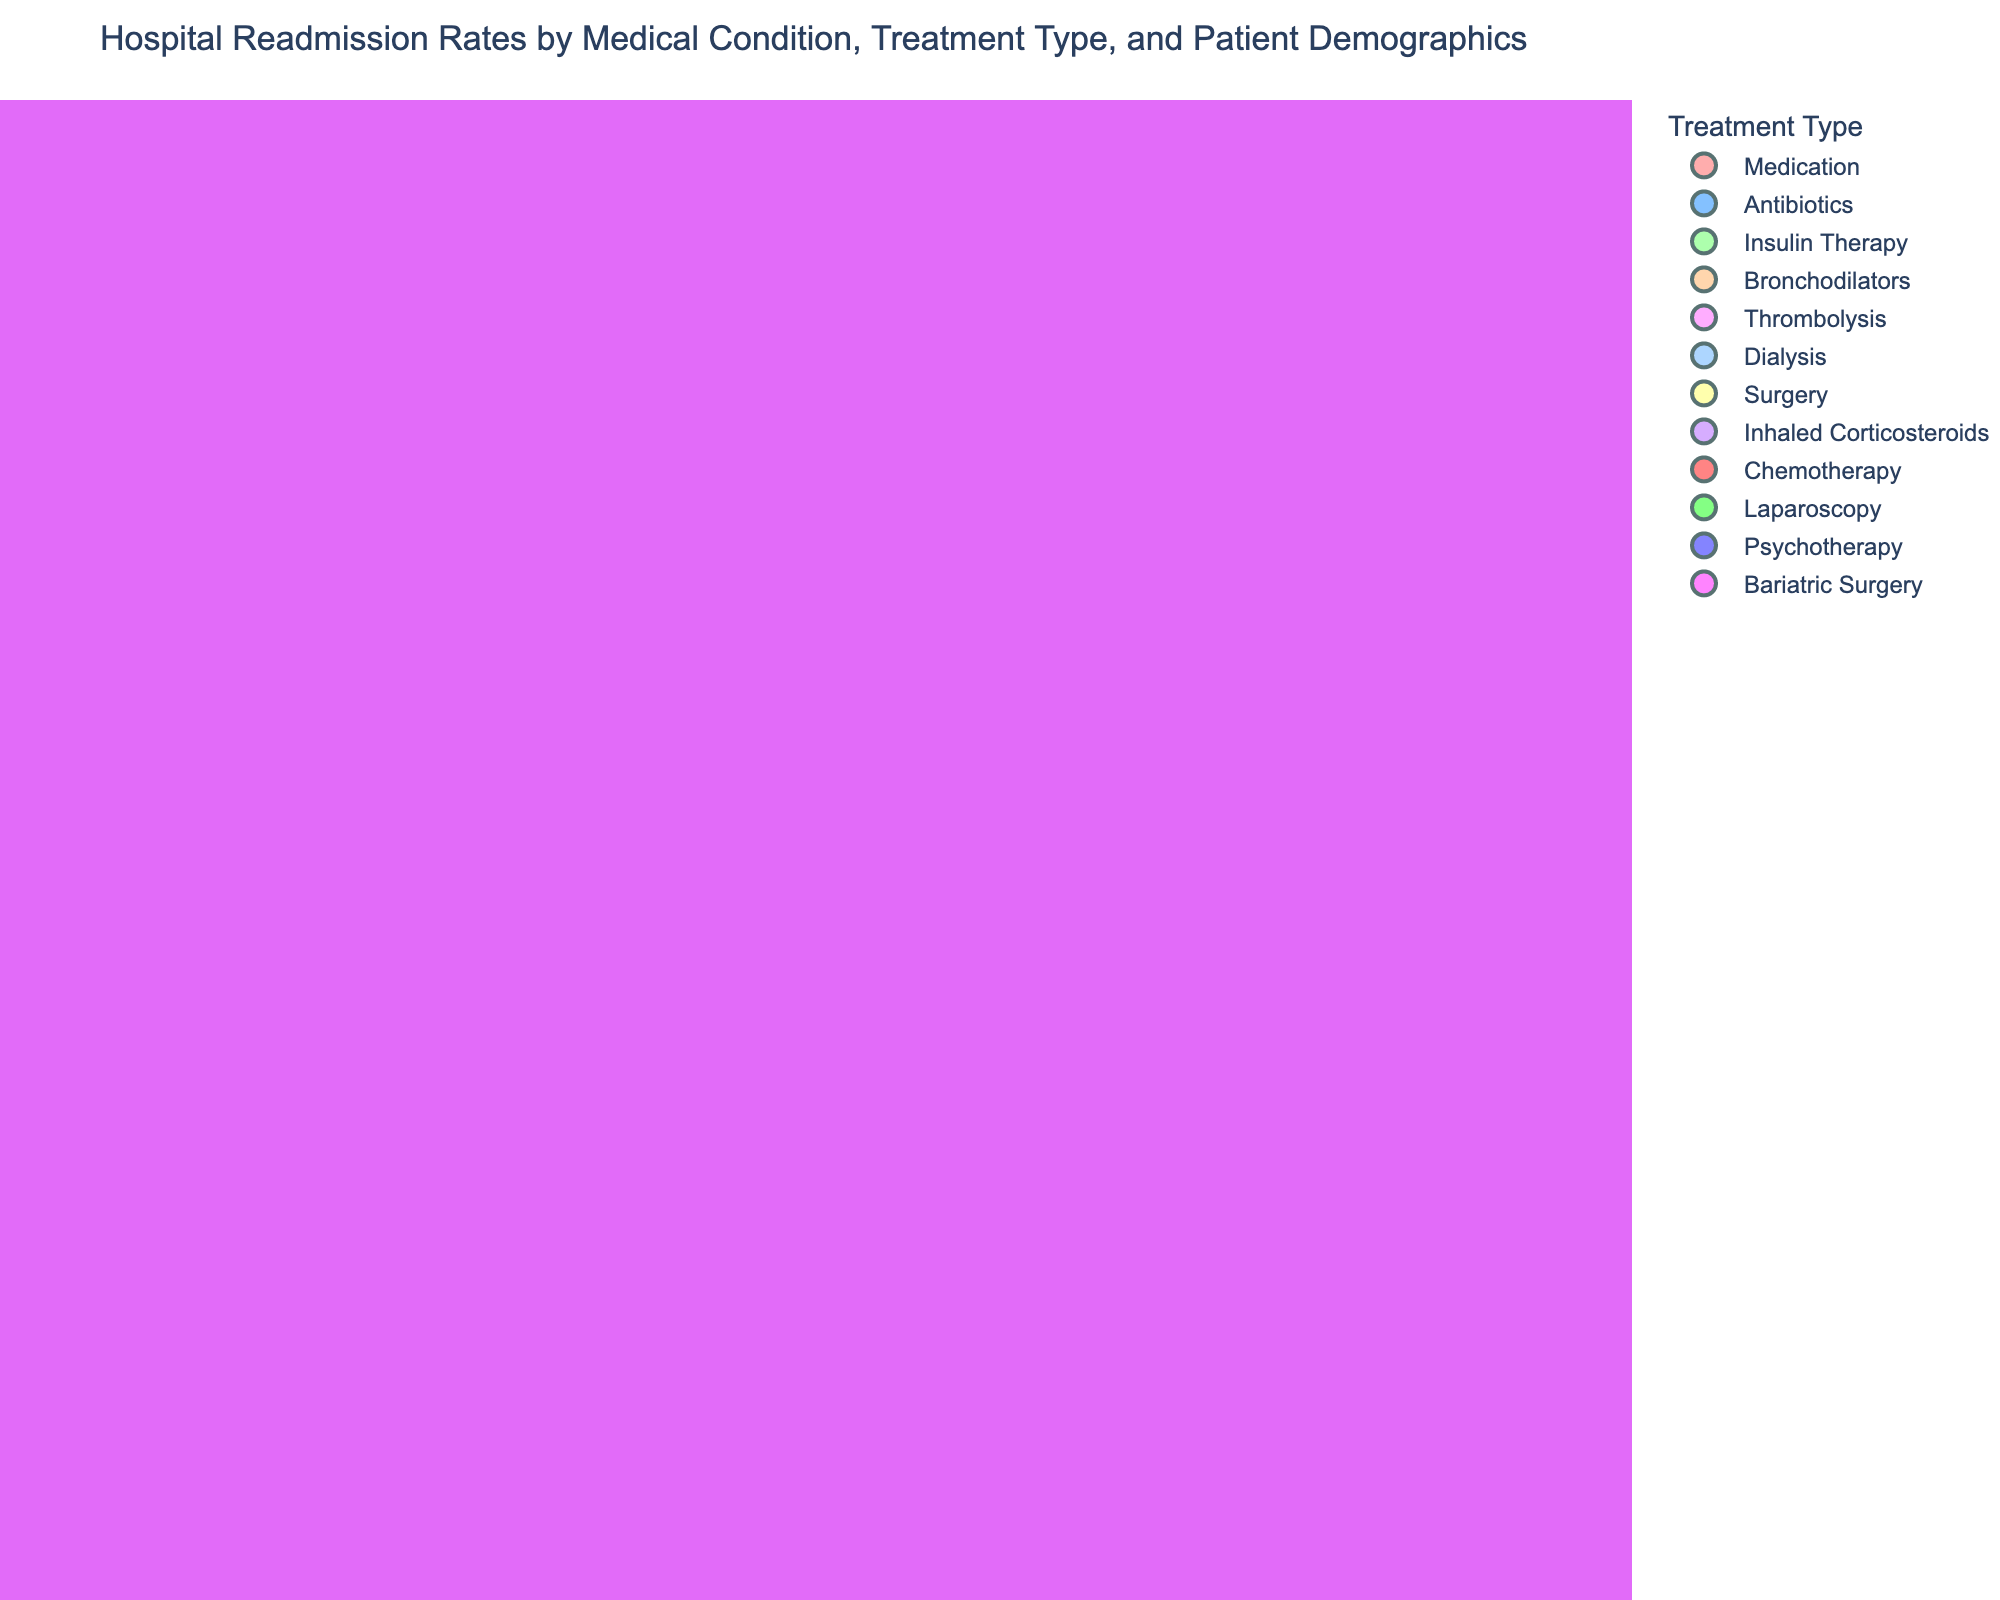What is the color used to represent 'Chemotherapy' treatment type? The bubble color for 'Chemotherapy' treatment type can be identified by checking the color legend in the figure. The legend shows 'Chemotherapy' corresponding to a specific color.
Answer: The bubble color for 'Chemotherapy' is dark red What is the title of the figure? The title of the figure is displayed at the top of the chart in a larger, bold font to clearly indicate what the plot represents.
Answer: Hospital Readmission Rates by Medical Condition, Treatment Type, and Patient Demographics Which medical condition has the highest readmission rate? To find the medical condition with the highest readmission rate, locate the bubble at the highest position along the 'Readmission Rate' (z) axis.
Answer: Cancer What is the total number of patients for the medical condition 'Heart Failure'? Find the bubble corresponding to 'Heart Failure' and refer to the hover data or the size proportion in the legend where 'Total Patients' is displayed.
Answer: 5000 How do the readmission rates for 'Kidney Failure' and 'Pneumonia' compare? Locate the bubbles for 'Kidney Failure' and 'Pneumonia' by their medical condition and compare their positions on the 'Readmission Rate' (z) axis to see which is higher.
Answer: The readmission rate for 'Kidney Failure' is higher than for 'Pneumonia' What is the average readmission rate for patients aged 65+? Identify the bubbles corresponding to the '65+' age group and find their 'Readmission Rate' values. Then calculate the average of these values. The conditions included are Heart Failure, COPD, Stroke, Hip Fracture, and Hypertension. Their readmission rates are 18.5, 15.6, 14.2, 11.8, and 10.5 respectively.
Answer: The average readmission rate for patients aged 65+ is (18.5 + 15.6 + 14.2 + 11.8 + 10.5) / 5 = 14.12% What is the treatment type for the condition with the lowest readmission rate? Look for the bubble positioned at the lowest point on the 'Readmission Rate' (z) axis and refer to its color and the legend to find the treatment type.
Answer: Surgery (Appendicitis) Which patient age group has the highest total number of patients? Compare the sizes of the bubbles across different age groups, as larger bubbles represent higher total patient numbers. The age groups to compare are clearly labeled and the size indicates the total patients. The '65+' age group with Heart Failure has the highest individual bubble size.
Answer: 65+ What is the combined total number of patients for 'Insulin Therapy' and 'Antibiotics' treatments? Find the bubbles representing 'Insulin Therapy' and 'Antibiotics', then look at their 'Total Patients' and sum these numbers. 'Insulin Therapy' (Diabetes) has 2800 patients and 'Antibiotics' (Pneumonia and Sepsis) has 3500 + 2300 patients. Combined total patients are 2800 + 3500 + 2300.
Answer: The combined total number of patients for 'Insulin Therapy' and 'Antibiotics' treatments is 8600 